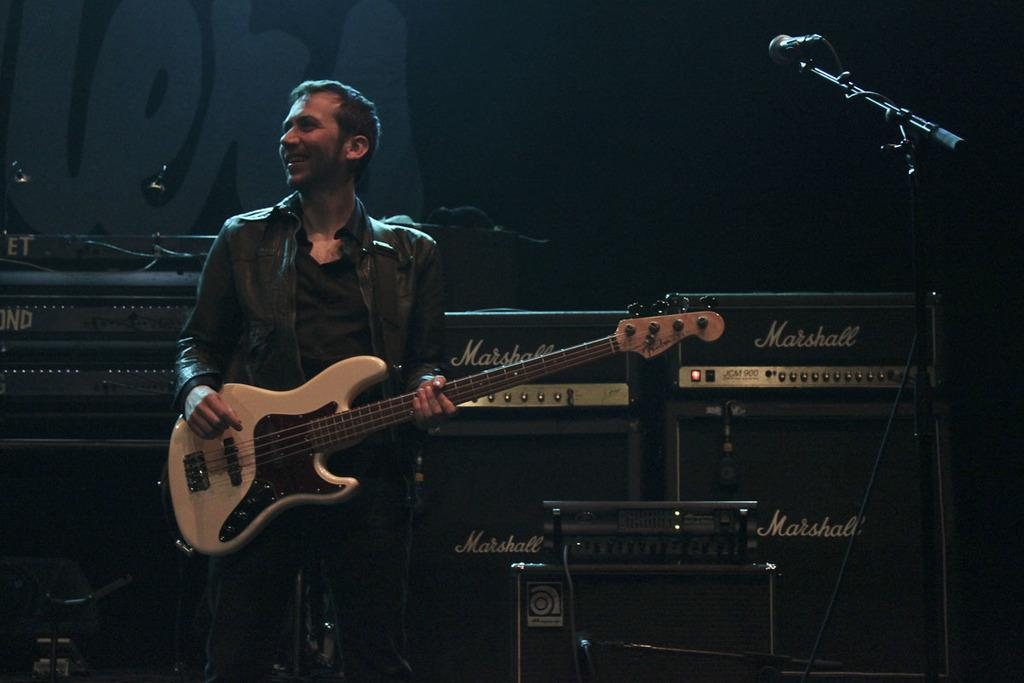What is the man in the image doing? The man is playing a guitar in the image. How is the man positioned in the image? The man is standing in the image. What expression does the man have on his face? The man has a smile on his face in the image. What object is present in the image that is commonly used for amplifying sound? There is a microphone in the image. What type of nail is the man using to play the guitar in the image? The man is not using a nail to play the guitar in the image; he is using his fingers or a guitar pick. What message is the man conveying with his good-bye gesture in the image? There is no good-bye gesture present in the image; the man is smiling and playing a guitar. 